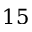Convert formula to latex. <formula><loc_0><loc_0><loc_500><loc_500>1 5</formula> 